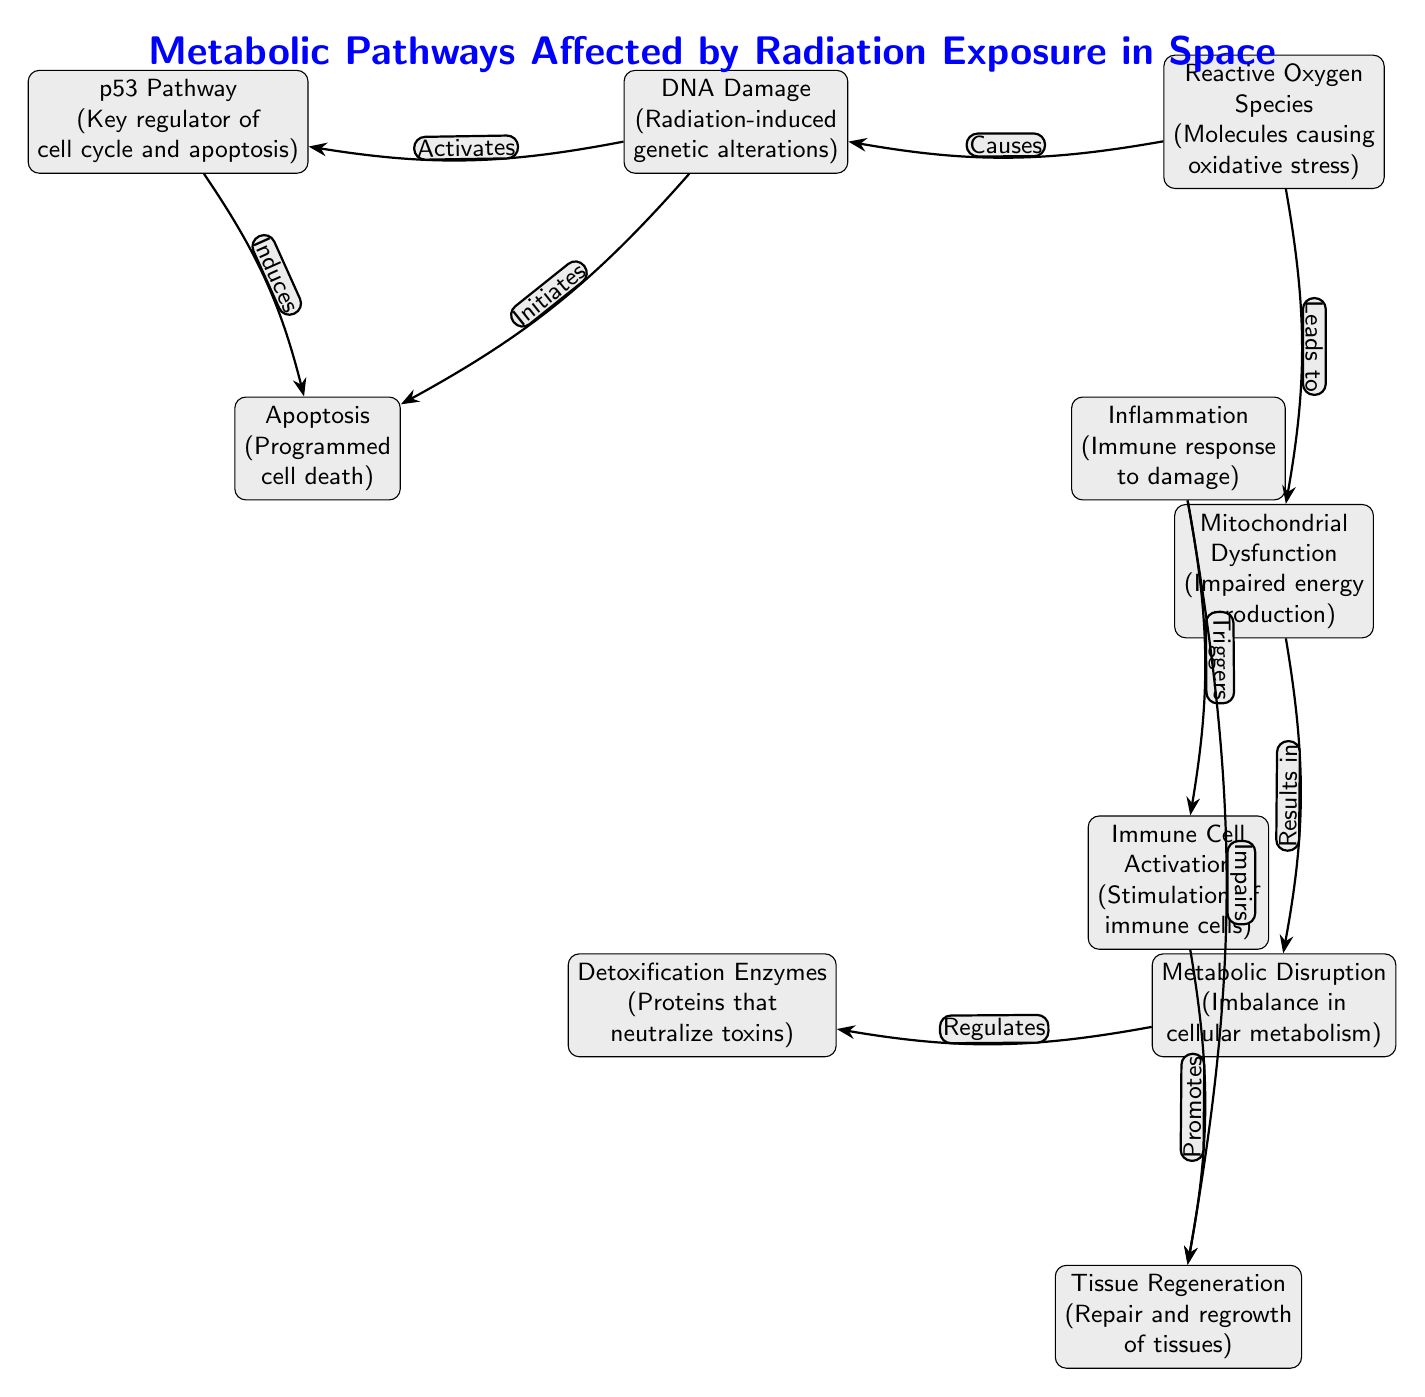What is the first node in the diagram? The first node, which is the origin of the flow in the diagram, is "DNA Damage (Radiation-induced genetic alterations)". This can be identified as it is the topmost node from which other connections stem.
Answer: DNA Damage How many nodes are there in total? The diagram features a total of 10 nodes, which can be counted from the listed components representing various biological effects and pathways.
Answer: 10 What does the DNA Damage node activate? The DNA Damage node activates the p53 Pathway, indicated by the directed edge labeled "Activates" coming from DNA Damage to p53. This relationship shows that DNA damage initiates the regulatory action of the p53 pathway.
Answer: p53 Pathway Which node is triggered by Inflammation? The Inflammation node triggers the Immune Cell Activation, as represented by the edge labeled "Triggers" connecting Inflammation to Immune Cell Activation in the diagram.
Answer: Immune Cell Activation What is the relationship between Reactive Oxygen Species and Mitochondrial Dysfunction? Reactive Oxygen Species (ROS) causes Mitochondrial Dysfunction, as the diagram shows a directed edge from ROS to Mitochondrial Dysfunction labeled "Leads to". This illustrates that the presence of ROS negatively impacts mitochondrial function.
Answer: Causes What does Metabolic Disruption regulate? Metabolic Disruption regulates Detoxification Enzymes, as indicated by the edge labeled "Regulates" connecting Metabolic Disruption to Detoxification Enzymes, showing a direct regulatory influence of metabolic changes on detoxification processes.
Answer: Detoxification Enzymes Which node induces Apoptosis? The Apoptosis node is induced by two influences: the p53 Pathway and DNA Damage. This can be deduced from the two directed edges labeled "Induces" and "Initiates" that point from these nodes to Apoptosis, confirming their role in promoting cell death.
Answer: p53 Pathway, DNA Damage What effect does Inflammation have on Tissue Regeneration? Inflammation impairs Tissue Regeneration, as evidenced by the edge labeled "Impairs" which shows a directed flow from Inflammation to Tissue Regeneration, illustrating a negative relationship between these two processes.
Answer: Impairs What is the endpoint of the pathway initiated by DNA Damage? The endpoint of the pathway initiated by DNA Damage is Tissue Regeneration, illustrating a complex interconnection among other nodes before reaching this final outcome. To reach this answer, one can trace the connections starting at DNA Damage down through the linked nodes as indicated by the diagram.
Answer: Tissue Regeneration 